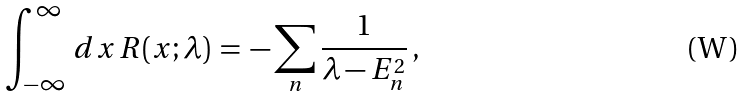Convert formula to latex. <formula><loc_0><loc_0><loc_500><loc_500>\int _ { - \infty } ^ { \infty } \, d x \, R ( x ; \lambda ) \, = \, - \sum _ { n } \frac { 1 } { \lambda - E _ { n } ^ { 2 } } \, ,</formula> 